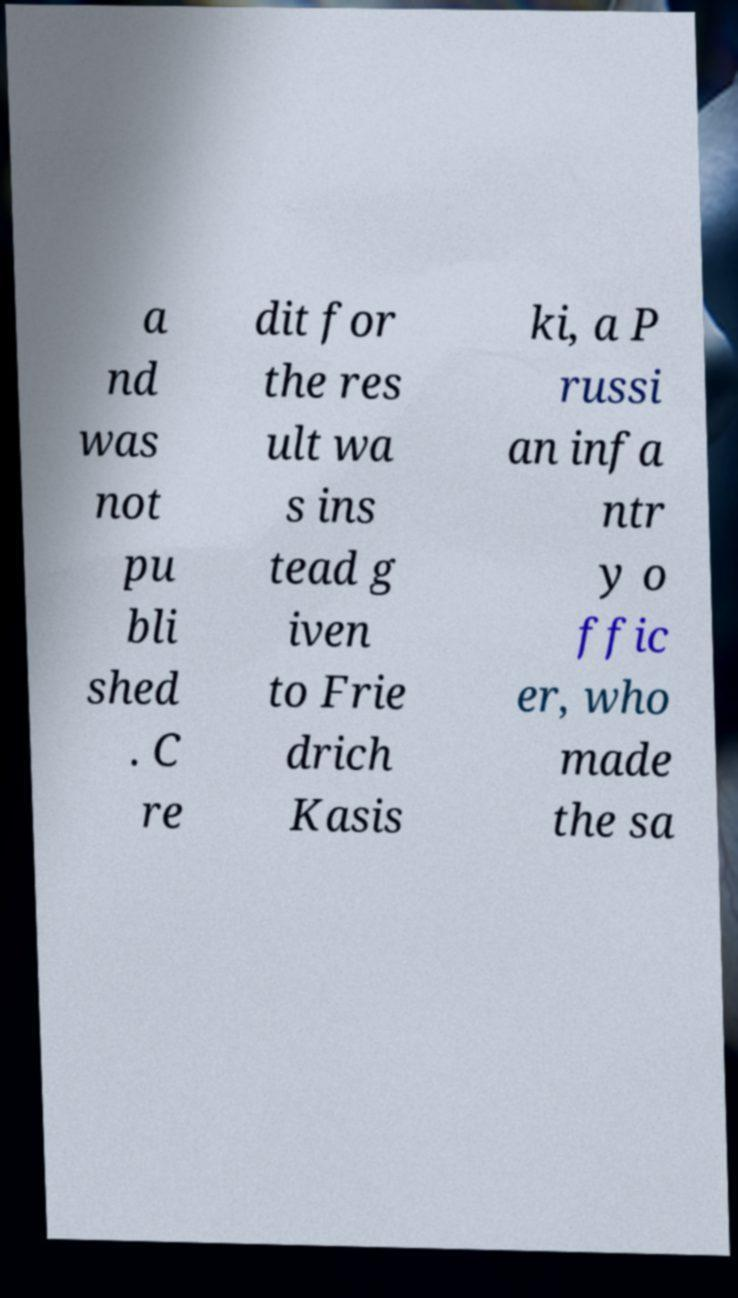Can you read and provide the text displayed in the image?This photo seems to have some interesting text. Can you extract and type it out for me? a nd was not pu bli shed . C re dit for the res ult wa s ins tead g iven to Frie drich Kasis ki, a P russi an infa ntr y o ffic er, who made the sa 